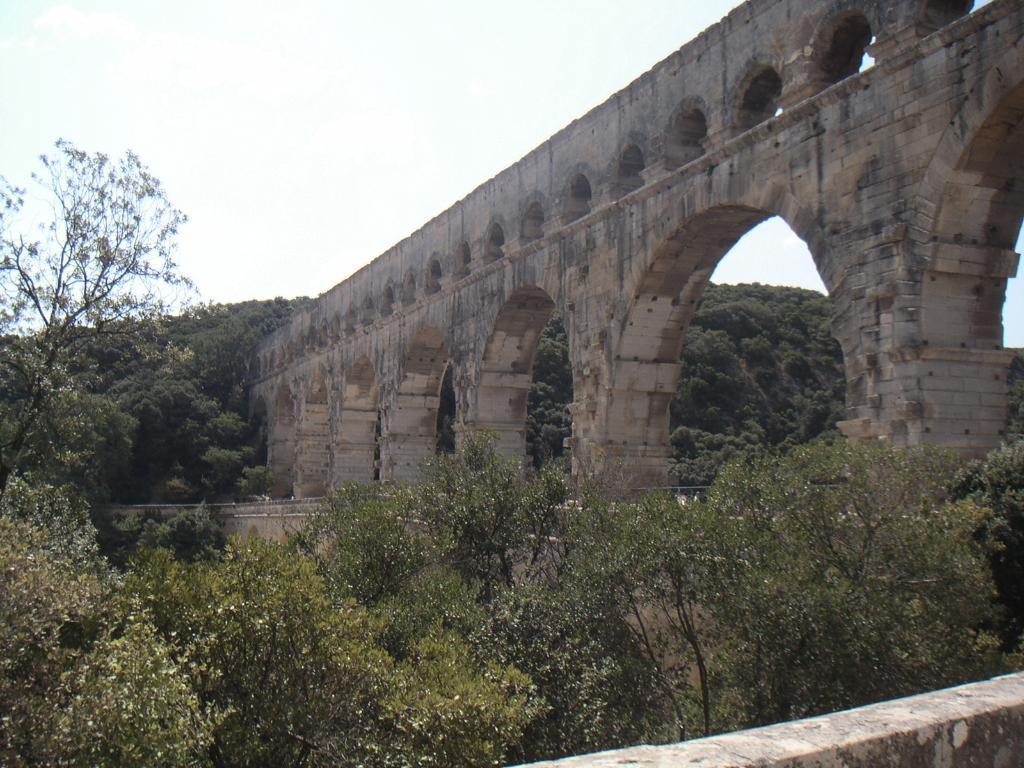How would you summarize this image in a sentence or two? This image consists of a bridge to which there are many arches. At the bottom, there are trees. At the top, there are clouds in the sky. 